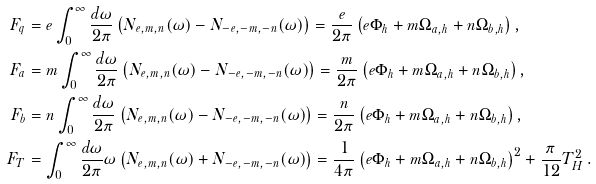<formula> <loc_0><loc_0><loc_500><loc_500>F _ { q } & = e \int _ { 0 } ^ { \infty } \frac { d \omega } { 2 \pi } \left ( N _ { e , m , n } ( \omega ) - N _ { - e , - m , - n } ( \omega ) \right ) = \frac { e } { 2 \pi } \left ( e \Phi _ { h } + m \Omega _ { a , h } + n \Omega _ { b , h } \right ) , \\ F _ { a } & = m \int _ { 0 } ^ { \infty } \frac { d \omega } { 2 \pi } \left ( N _ { e , m , n } ( \omega ) - N _ { - e , - m , - n } ( \omega ) \right ) = \frac { m } { 2 \pi } \left ( e \Phi _ { h } + m \Omega _ { a , h } + n \Omega _ { b , h } \right ) , \\ F _ { b } & = n \int _ { 0 } ^ { \infty } \frac { d \omega } { 2 \pi } \left ( N _ { e , m , n } ( \omega ) - N _ { - e , - m , - n } ( \omega ) \right ) = \frac { n } { 2 \pi } \left ( e \Phi _ { h } + m \Omega _ { a , h } + n \Omega _ { b , h } \right ) , \\ F _ { T } & = \int _ { 0 } ^ { \infty } \frac { d \omega } { 2 \pi } \omega \left ( N _ { e , m , n } ( \omega ) + N _ { - e , - m , - n } ( \omega ) \right ) = \frac { 1 } { 4 \pi } \left ( e \Phi _ { h } + m \Omega _ { a , h } + n \Omega _ { b , h } \right ) ^ { 2 } + \frac { \pi } { 1 2 } T _ { H } ^ { 2 } \, .</formula> 